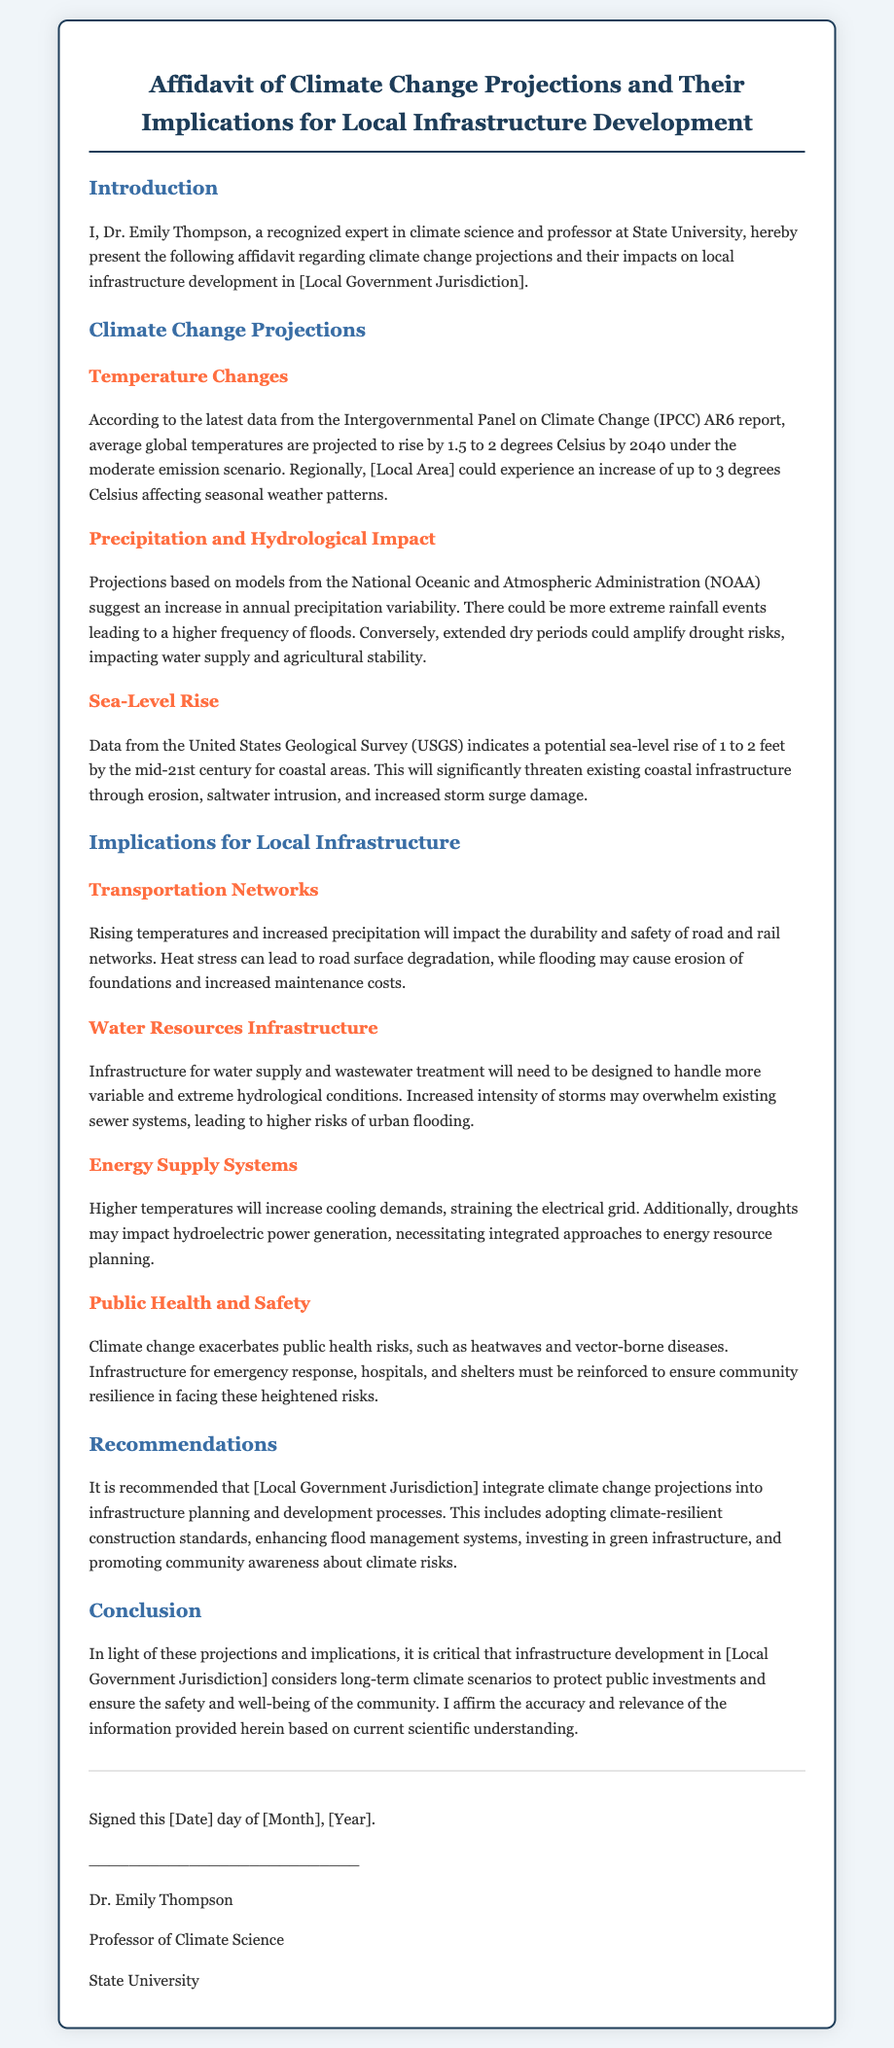What is the name of the expert presenting the affidavit? The document states Dr. Emily Thompson is the recognized expert presenting the affidavit.
Answer: Dr. Emily Thompson What is the projected increase in temperature by 2040? The document indicates a projected rise in average global temperatures by 1.5 to 2 degrees Celsius by 2040.
Answer: 1.5 to 2 degrees Celsius What is the potential sea-level rise by the mid-21st century? According to the document, the sea-level rise is projected to be 1 to 2 feet by the mid-21st century for coastal areas.
Answer: 1 to 2 feet Which organization provides the data for temperature changes? The latest data for temperature changes is from the Intergovernmental Panel on Climate Change (IPCC).
Answer: Intergovernmental Panel on Climate Change (IPCC) What is a recommendation for local infrastructure development? The document recommends integrating climate change projections into infrastructure planning and development processes.
Answer: Integrate climate change projections How do increased precipitation and temperature affect transportation networks? Increased precipitation and temperature impact the durability and safety of road and rail networks as stated in the document.
Answer: Durability and safety What type of risks does climate change exacerbate according to the affidavit? The affidavit notes that climate change exacerbates public health risks, including heatwaves and vector-borne diseases.
Answer: Public health risks What is the significance of the signed date in the document? The signed date indicates when Dr. Emily Thompson confirmed the affidavit's information and relevance.
Answer: Confirmation date 